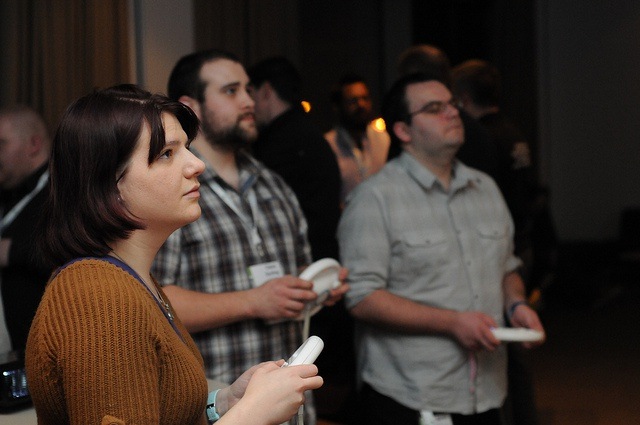Describe the objects in this image and their specific colors. I can see people in black, maroon, and brown tones, people in black, gray, maroon, and brown tones, people in black, gray, and maroon tones, people in black, maroon, and gray tones, and people in black, maroon, gray, and brown tones in this image. 